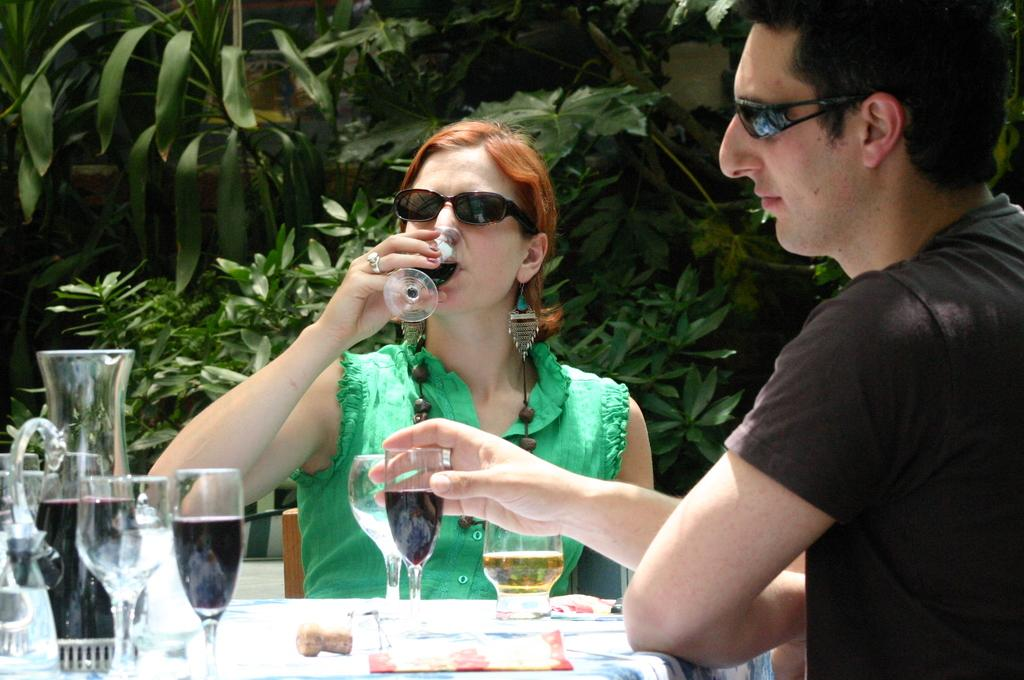Who is present in the image? There is a woman in the image. What is the woman wearing? The woman is wearing a green dress. What is the woman doing in the image? The woman is sitting in a chair and drinking wine. Who is beside the woman? There is a person beside the woman. What is the person holding? The person is holding a glass. Where is the glass placed? The glass is on a table. What can be seen in the background of the image? There are trees in the background of the image. What type of sheet is covering the swimming pool in the image? There is no swimming pool or sheet present in the image. 